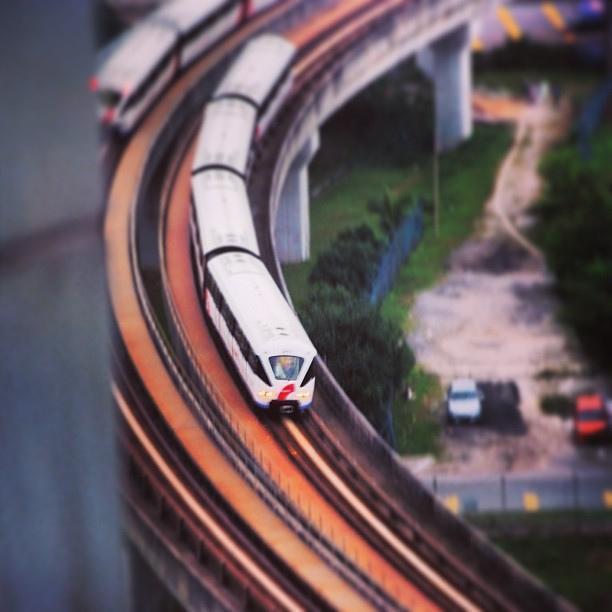How many red cars are there?
Give a very brief answer. 1. How many trains are visible?
Give a very brief answer. 2. 